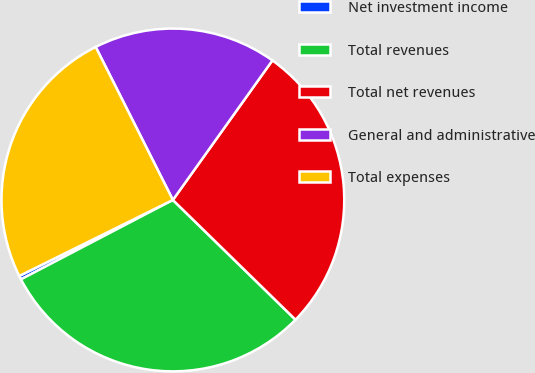<chart> <loc_0><loc_0><loc_500><loc_500><pie_chart><fcel>Net investment income<fcel>Total revenues<fcel>Total net revenues<fcel>General and administrative<fcel>Total expenses<nl><fcel>0.35%<fcel>30.03%<fcel>27.45%<fcel>17.3%<fcel>24.88%<nl></chart> 